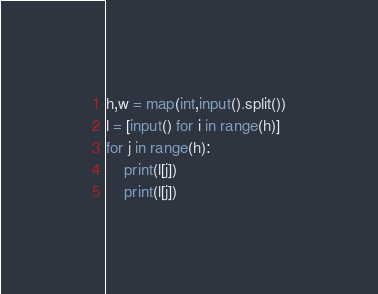Convert code to text. <code><loc_0><loc_0><loc_500><loc_500><_Python_>h,w = map(int,input().split())
l = [input() for i in range(h)]
for j in range(h):
    print(l[j])
    print(l[j])</code> 